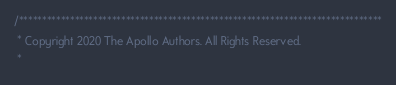<code> <loc_0><loc_0><loc_500><loc_500><_C++_>/******************************************************************************
 * Copyright 2020 The Apollo Authors. All Rights Reserved.
 *</code> 